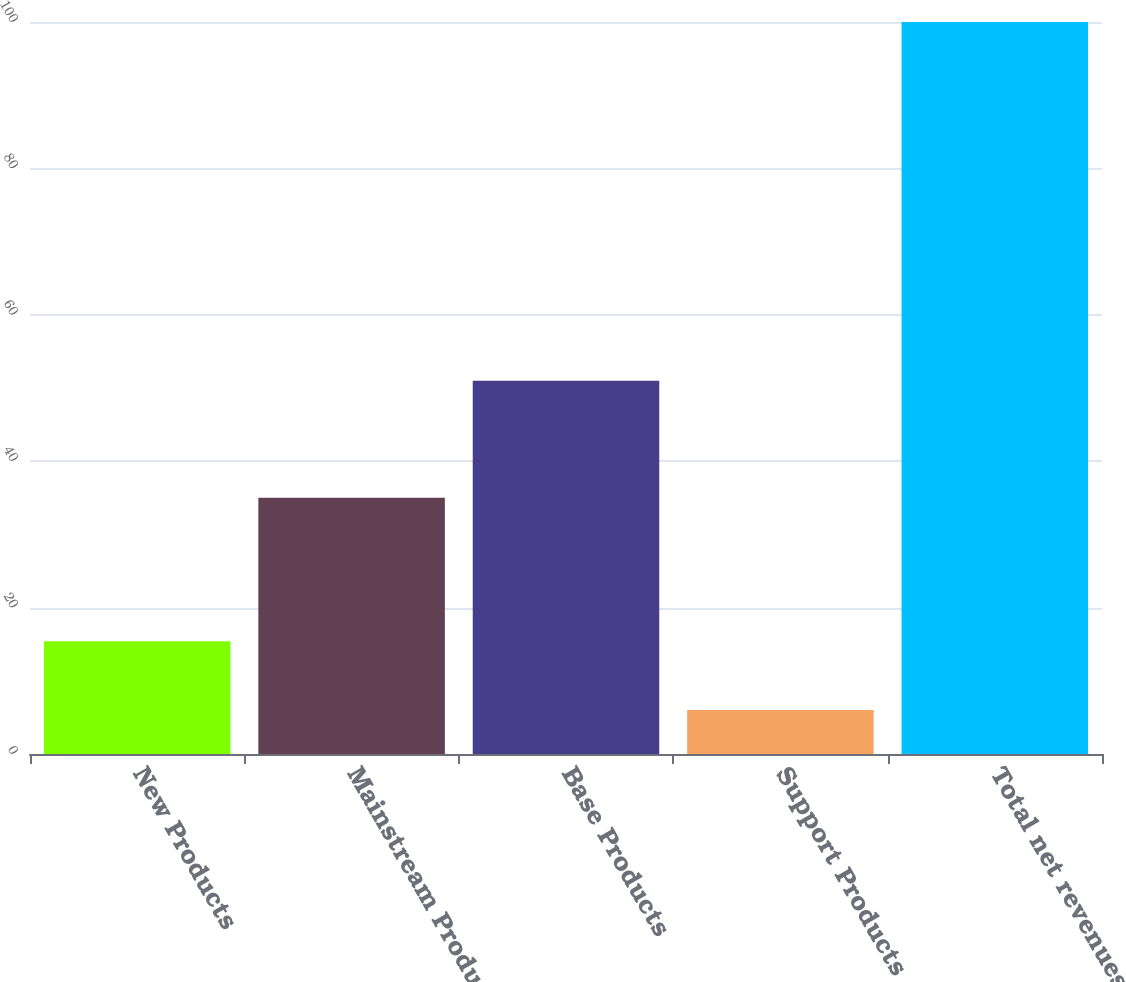Convert chart to OTSL. <chart><loc_0><loc_0><loc_500><loc_500><bar_chart><fcel>New Products<fcel>Mainstream Products<fcel>Base Products<fcel>Support Products<fcel>Total net revenues<nl><fcel>15.4<fcel>35<fcel>51<fcel>6<fcel>100<nl></chart> 